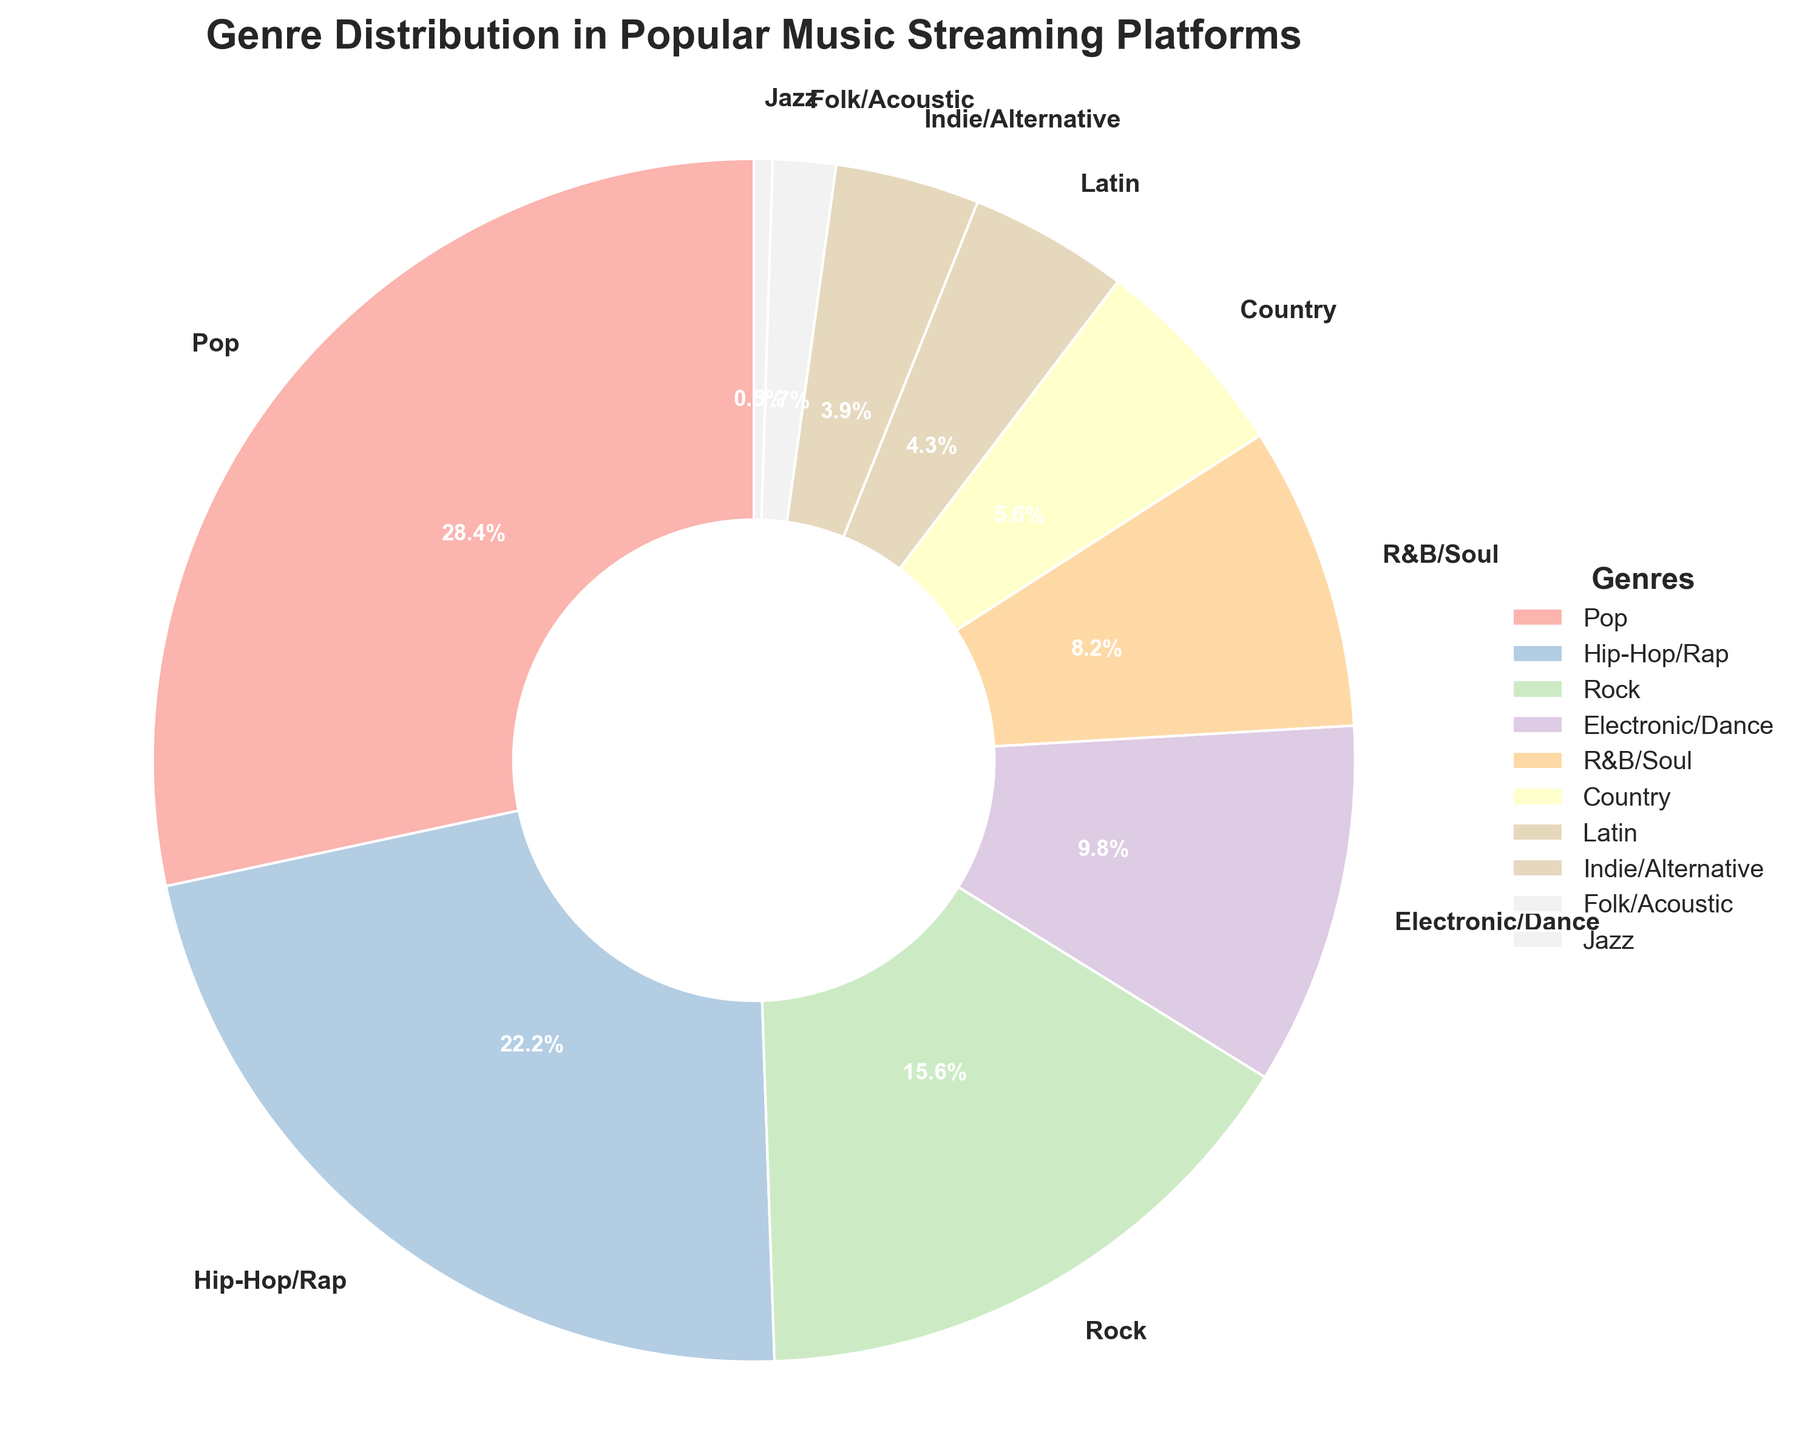Which genre has the highest percentage distribution? To identify the genre with the highest percentage, look for the largest slice in the pie and check the label. The genre with the highest percentage is Pop with 28.5%.
Answer: Pop What is the combined percentage of Pop and Hip-Hop/Rap genres? Add the percentages of both genres: Pop (28.5%) and Hip-Hop/Rap (22.3%). The combined percentage is 28.5 + 22.3 = 50.8%.
Answer: 50.8% Is the percentage of Electronic/Dance higher than that of R&B/Soul? Compare the percentages of Electronic/Dance (9.8%) and R&B/Soul (8.2%). Since 9.8 is greater than 8.2, Electronic/Dance has a higher percentage.
Answer: Yes How much more popular is Pop compared to Rock? Subtract the Rock percentage (15.7%) from the Pop percentage (28.5%). The difference is 28.5 - 15.7 = 12.8 percentage points.
Answer: 12.8 percentage points Which genres have a percentage lower than 5%? Review the segments of the pie chart for genres below 5%. The genres with less than 5% are Latin (4.3%), Indie/Alternative (3.9%), Folk/Acoustic (1.7%), and Jazz (0.5%).
Answer: Latin, Indie/Alternative, Folk/Acoustic, Jazz What is the total percentage of genres under 10%? Sum the percentages of Electronic/Dance (9.8%), R&B/Soul (8.2%), Country (5.6%), Latin (4.3%), Indie/Alternative (3.9%), Folk/Acoustic (1.7%), and Jazz (0.5%). The total is 9.8 + 8.2 + 5.6 + 4.3 + 3.9 + 1.7 + 0.5 = 34%.
Answer: 34% Which genre has the smallest percentage in the chart? Identify the smallest slice by size and label. The genre with the smallest percentage is Jazz, with 0.5%.
Answer: Jazz Are there more genres with a percentage higher than 10% or those with a percentage lower than 10%? Count the genres above and below 10%: Above 10%: Pop (28.5%), Hip-Hop/Rap (22.3%), Rock (15.7%) = 3 genres. Below 10%: Electronic/Dance, R&B/Soul, Country, Latin, Indie/Alternative, Folk/Acoustic, Jazz = 7 genres. More genres have a percentage below 10%.
Answer: More below 10% Between Country and R&B/Soul, which genre is more popular? Compare the percentages of Country (5.6%) and R&B/Soul (8.2%). R&B/Soul has a higher percentage than Country.
Answer: R&B/Soul What is the percentage difference between Indie/Alternative and Folk/Acoustic? Subtract the percentage of Folk/Acoustic (1.7%) from Indie/Alternative (3.9%). The difference is 3.9 - 1.7 = 2.2 percentage points.
Answer: 2.2 percentage points 